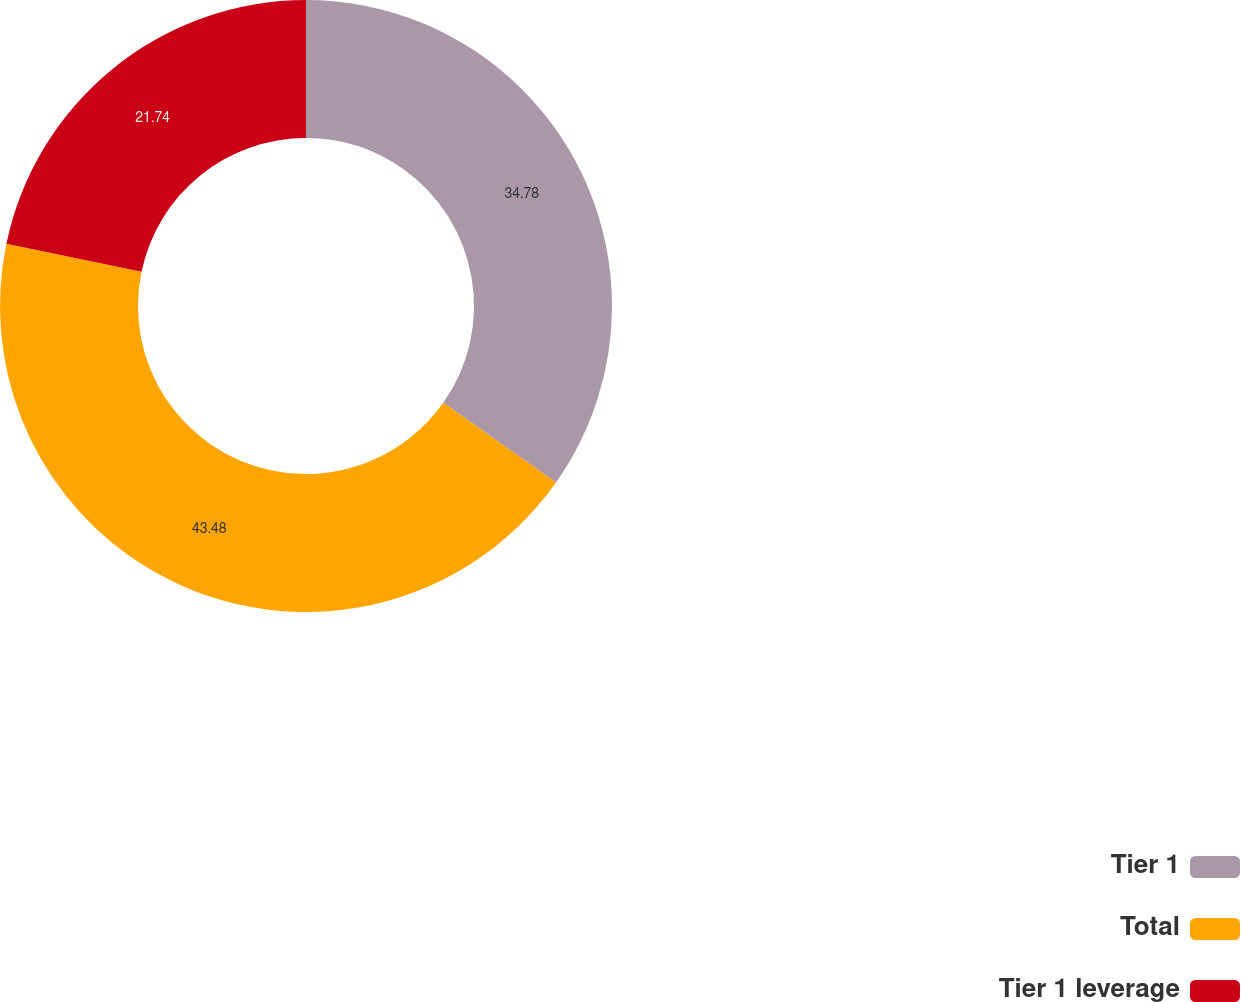Convert chart. <chart><loc_0><loc_0><loc_500><loc_500><pie_chart><fcel>Tier 1<fcel>Total<fcel>Tier 1 leverage<nl><fcel>34.78%<fcel>43.48%<fcel>21.74%<nl></chart> 